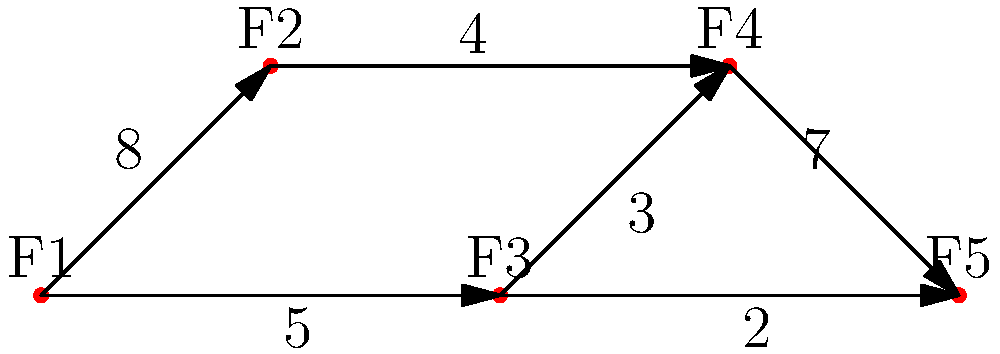In this graph-based representation of feature prioritization and dependencies, each node represents a feature (F1 to F5), and the edges represent dependencies with associated priority scores. What is the minimum priority score required to implement feature F5, considering all its dependencies? To determine the minimum priority score required to implement feature F5, we need to analyze all possible paths leading to F5 and their cumulative priority scores. Let's break it down step-by-step:

1. Identify all paths leading to F5:
   Path 1: F1 -> F2 -> F4 -> F5
   Path 2: F1 -> F3 -> F4 -> F5
   Path 3: F1 -> F3 -> F5

2. Calculate the cumulative priority score for each path:
   Path 1: 8 + 4 + 7 = 19
   Path 2: 5 + 3 + 7 = 15
   Path 3: 5 + 2 = 7

3. The minimum priority score required is the maximum of these cumulative scores because we need to ensure all dependencies are satisfied.

4. Compare the cumulative scores:
   max(19, 15, 7) = 19

Therefore, the minimum priority score required to implement feature F5, considering all its dependencies, is 19.
Answer: 19 